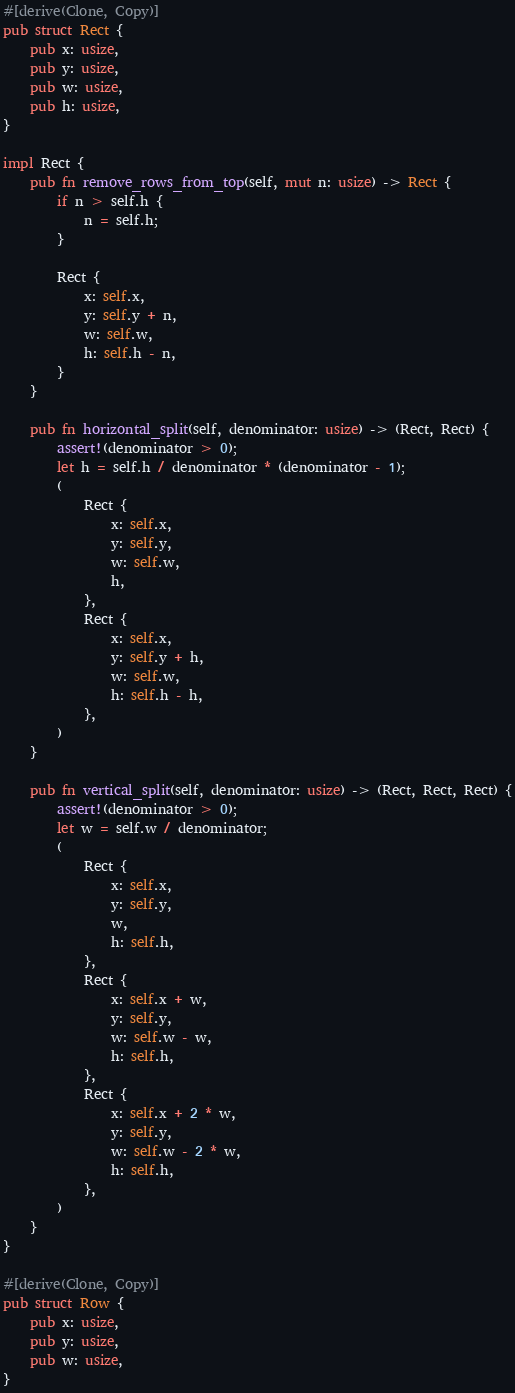Convert code to text. <code><loc_0><loc_0><loc_500><loc_500><_Rust_>#[derive(Clone, Copy)]
pub struct Rect {
    pub x: usize,
    pub y: usize,
    pub w: usize,
    pub h: usize,
}

impl Rect {
    pub fn remove_rows_from_top(self, mut n: usize) -> Rect {
        if n > self.h {
            n = self.h;
        }

        Rect {
            x: self.x,
            y: self.y + n,
            w: self.w,
            h: self.h - n,
        }
    }

    pub fn horizontal_split(self, denominator: usize) -> (Rect, Rect) {
        assert!(denominator > 0);
        let h = self.h / denominator * (denominator - 1);
        (
            Rect {
                x: self.x,
                y: self.y,
                w: self.w,
                h,
            },
            Rect {
                x: self.x,
                y: self.y + h,
                w: self.w,
                h: self.h - h,
            },
        )
    }

    pub fn vertical_split(self, denominator: usize) -> (Rect, Rect, Rect) {
        assert!(denominator > 0);
        let w = self.w / denominator;
        (
            Rect {
                x: self.x,
                y: self.y,
                w,
                h: self.h,
            },
            Rect {
                x: self.x + w,
                y: self.y,
                w: self.w - w,
                h: self.h,
            },
            Rect {
                x: self.x + 2 * w,
                y: self.y,
                w: self.w - 2 * w,
                h: self.h,
            },
        )
    }
}

#[derive(Clone, Copy)]
pub struct Row {
    pub x: usize,
    pub y: usize,
    pub w: usize,
}
</code> 